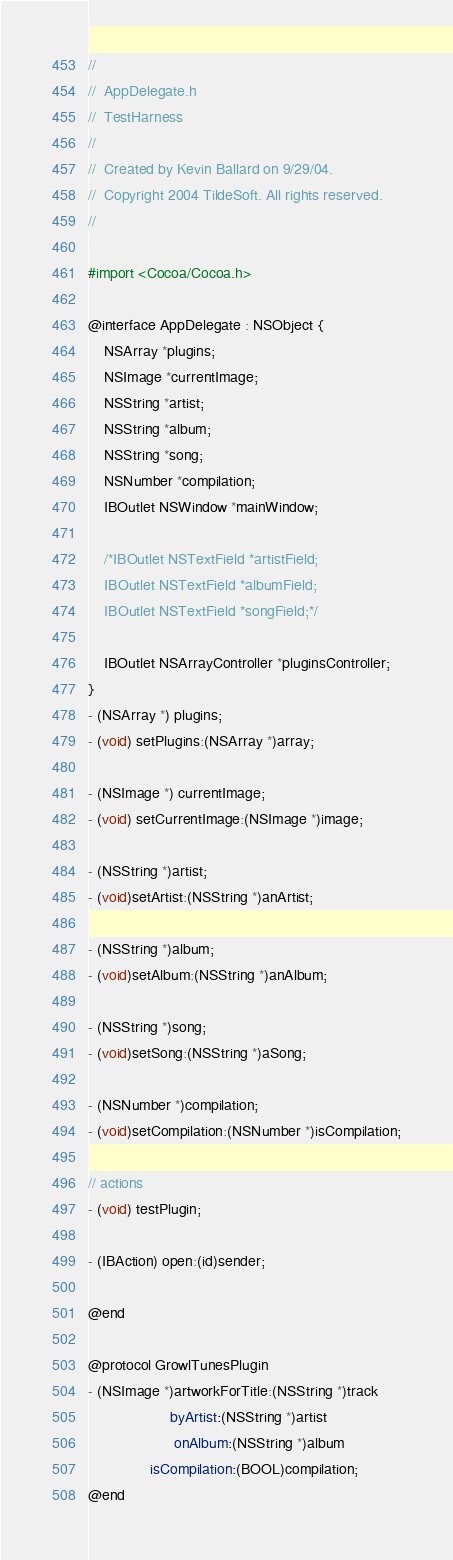<code> <loc_0><loc_0><loc_500><loc_500><_C_>//
//  AppDelegate.h
//  TestHarness
//
//  Created by Kevin Ballard on 9/29/04.
//  Copyright 2004 TildeSoft. All rights reserved.
//

#import <Cocoa/Cocoa.h>

@interface AppDelegate : NSObject {
	NSArray *plugins;
	NSImage *currentImage;
	NSString *artist;
	NSString *album;
	NSString *song;
	NSNumber *compilation;
	IBOutlet NSWindow *mainWindow;

	/*IBOutlet NSTextField *artistField;
	IBOutlet NSTextField *albumField;
	IBOutlet NSTextField *songField;*/

	IBOutlet NSArrayController *pluginsController;
}
- (NSArray *) plugins;
- (void) setPlugins:(NSArray *)array;

- (NSImage *) currentImage;
- (void) setCurrentImage:(NSImage *)image;

- (NSString *)artist;
- (void)setArtist:(NSString *)anArtist;

- (NSString *)album;
- (void)setAlbum:(NSString *)anAlbum;

- (NSString *)song;
- (void)setSong:(NSString *)aSong;

- (NSNumber *)compilation;
- (void)setCompilation:(NSNumber *)isCompilation;

// actions
- (void) testPlugin;

- (IBAction) open:(id)sender;

@end

@protocol GrowlTunesPlugin
- (NSImage *)artworkForTitle:(NSString *)track
					byArtist:(NSString *)artist
					 onAlbum:(NSString *)album
			   isCompilation:(BOOL)compilation;
@end
</code> 